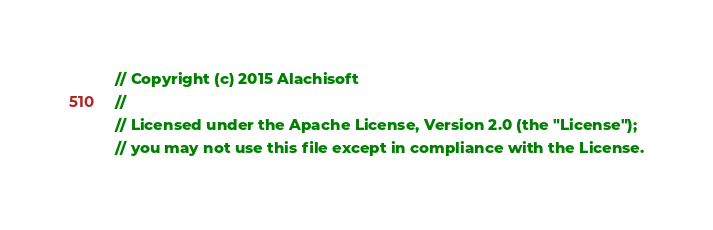<code> <loc_0><loc_0><loc_500><loc_500><_C#_>// Copyright (c) 2015 Alachisoft
// 
// Licensed under the Apache License, Version 2.0 (the "License");
// you may not use this file except in compliance with the License.</code> 